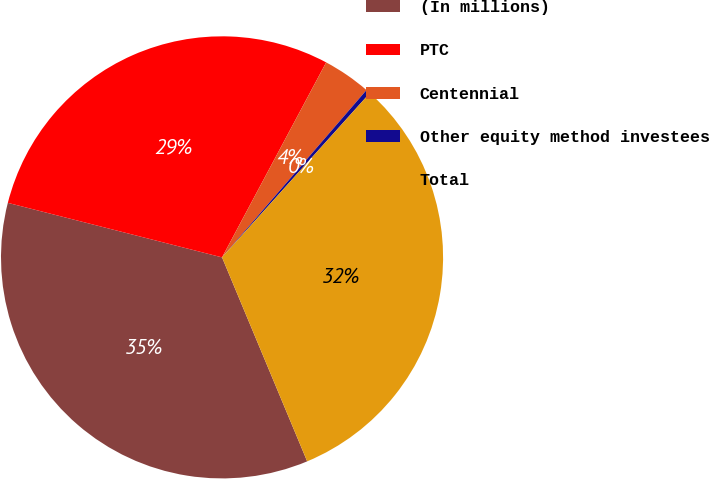<chart> <loc_0><loc_0><loc_500><loc_500><pie_chart><fcel>(In millions)<fcel>PTC<fcel>Centennial<fcel>Other equity method investees<fcel>Total<nl><fcel>35.26%<fcel>28.84%<fcel>3.53%<fcel>0.32%<fcel>32.05%<nl></chart> 